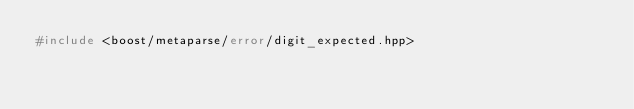<code> <loc_0><loc_0><loc_500><loc_500><_C++_>#include <boost/metaparse/error/digit_expected.hpp>
</code> 